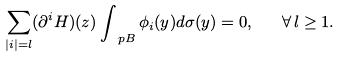<formula> <loc_0><loc_0><loc_500><loc_500>\sum _ { | i | = l } ( \partial ^ { i } H ) ( z ) \int _ { \ p B } \phi _ { i } ( y ) d \sigma ( y ) = 0 , \quad \forall \, l \geq 1 .</formula> 